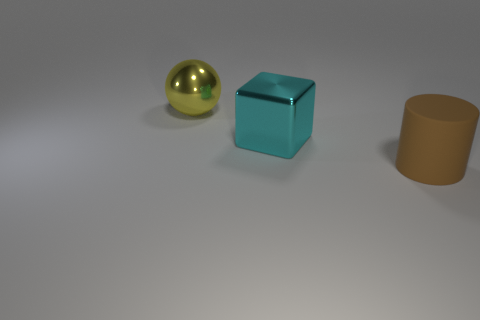Add 3 tiny objects. How many objects exist? 6 Subtract all cylinders. How many objects are left? 2 Add 2 large brown rubber objects. How many large brown rubber objects exist? 3 Subtract 0 blue spheres. How many objects are left? 3 Subtract 1 cylinders. How many cylinders are left? 0 Subtract all green cubes. Subtract all gray cylinders. How many cubes are left? 1 Subtract all small cyan metallic cylinders. Subtract all big metallic cubes. How many objects are left? 2 Add 3 large cyan blocks. How many large cyan blocks are left? 4 